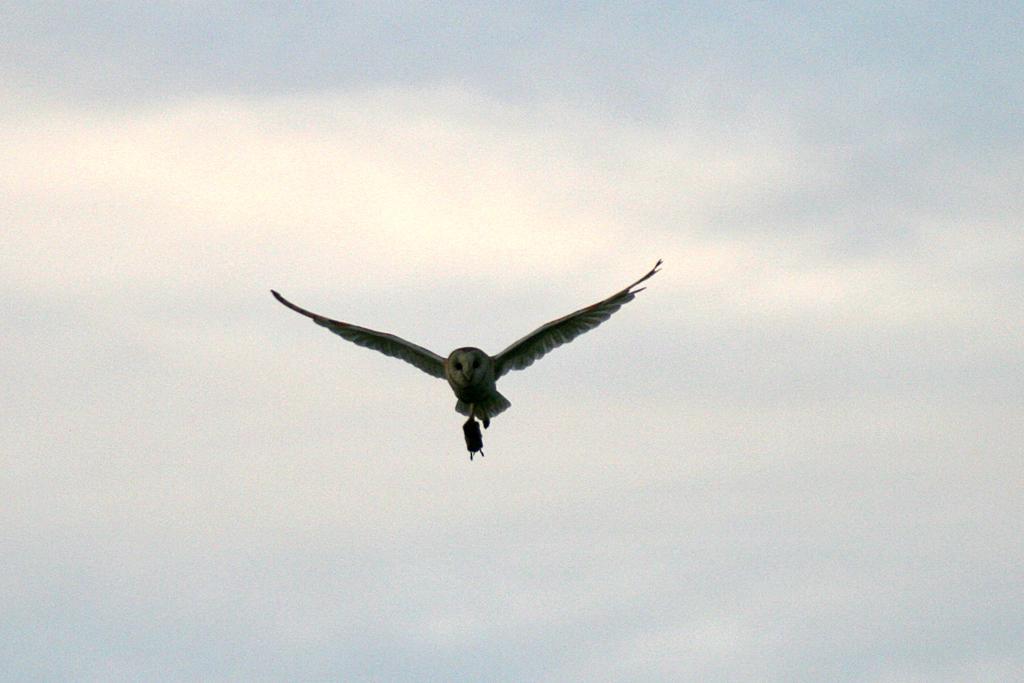Please provide a concise description of this image. There is a bird flying in the sky as we can see in the middle of this image, and there is a sky in the background. 